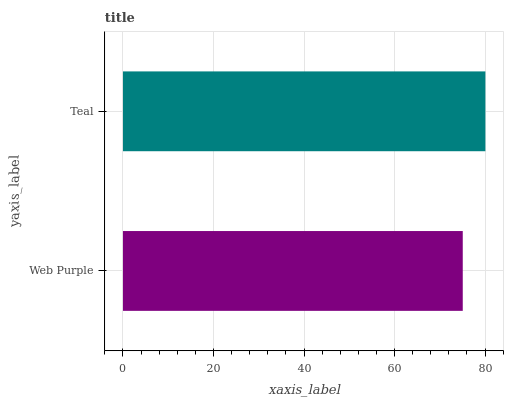Is Web Purple the minimum?
Answer yes or no. Yes. Is Teal the maximum?
Answer yes or no. Yes. Is Teal the minimum?
Answer yes or no. No. Is Teal greater than Web Purple?
Answer yes or no. Yes. Is Web Purple less than Teal?
Answer yes or no. Yes. Is Web Purple greater than Teal?
Answer yes or no. No. Is Teal less than Web Purple?
Answer yes or no. No. Is Teal the high median?
Answer yes or no. Yes. Is Web Purple the low median?
Answer yes or no. Yes. Is Web Purple the high median?
Answer yes or no. No. Is Teal the low median?
Answer yes or no. No. 